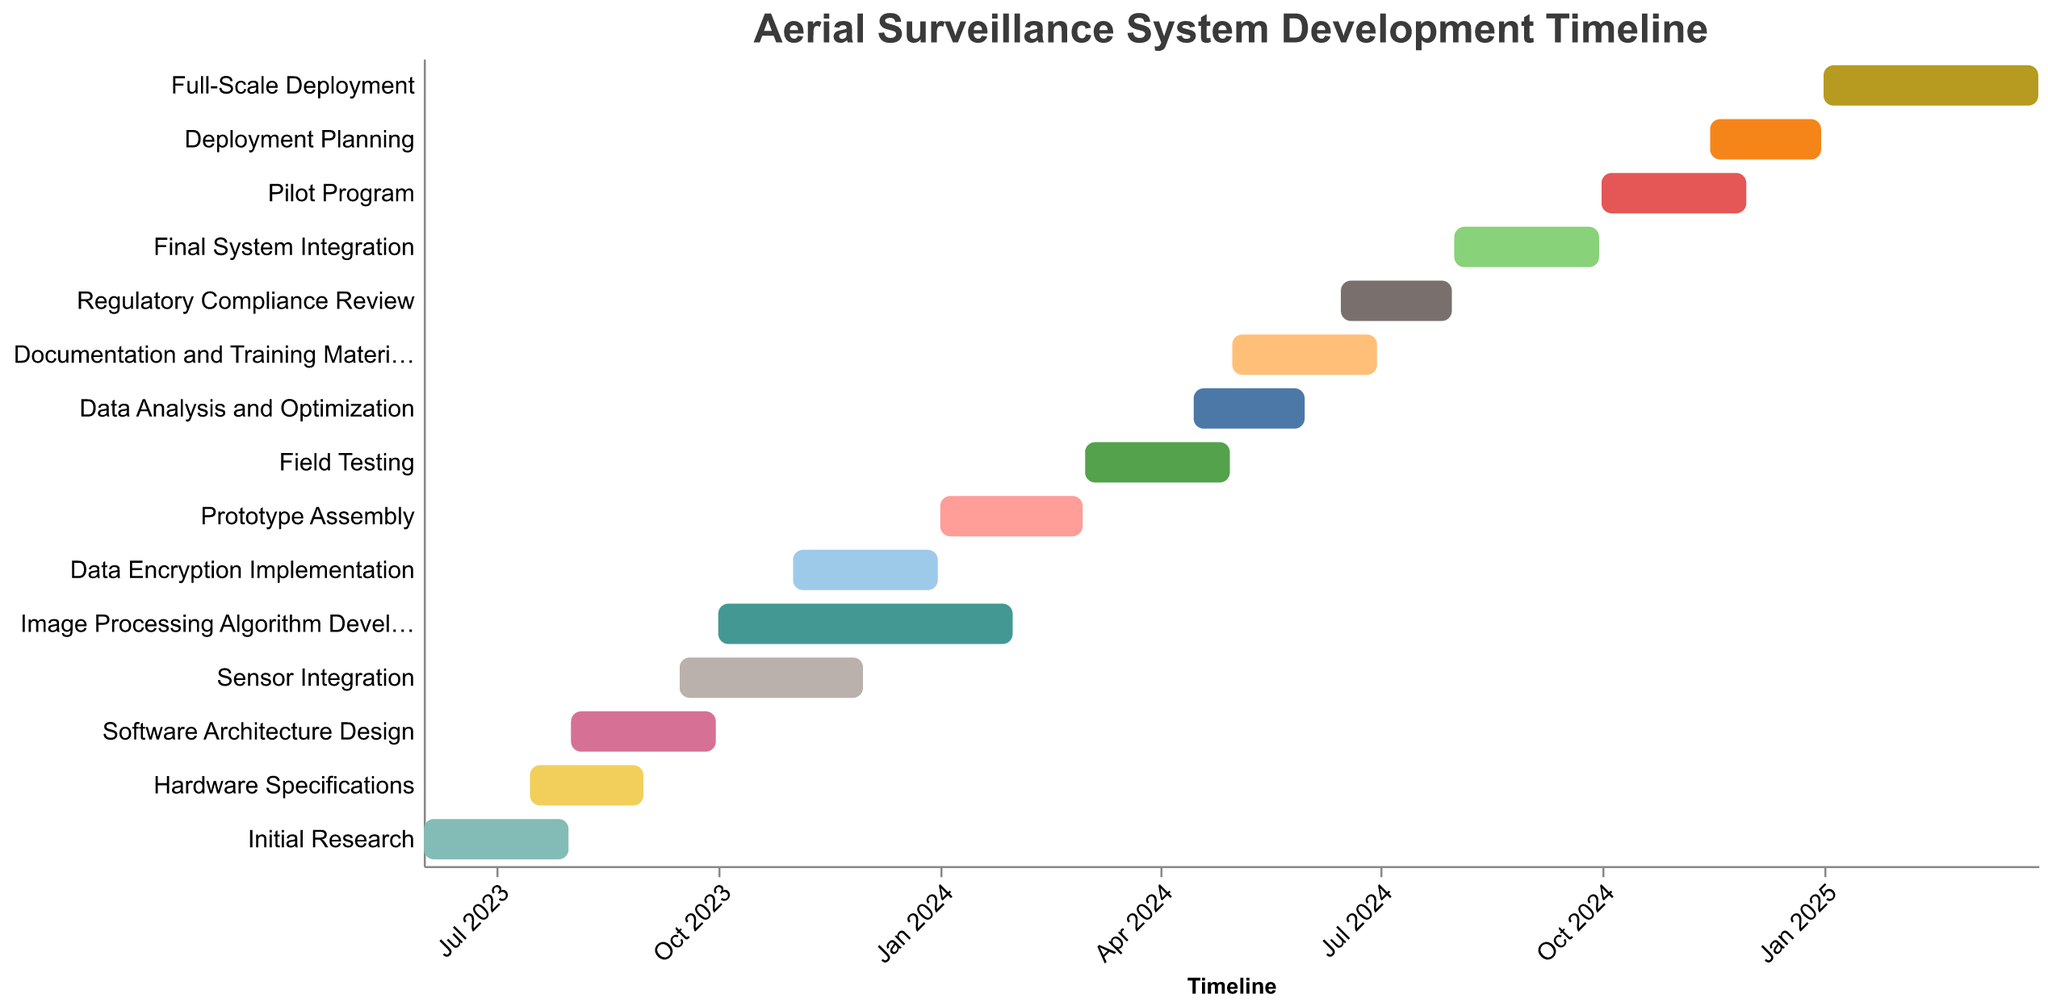What's the overall duration of the project from start to end? The project starts on 2023-06-01 and ends on 2025-03-31. The duration can be calculated by finding the difference between these two dates.
Answer: 669 days Which task has the longest duration? By comparing the durations listed, "Image Processing Algorithm Development" has the longest at 123 days.
Answer: Image Processing Algorithm Development How many tasks take place in the year 2023? Tasks happening in 2023 include Initial Research, Hardware Specifications, Software Architecture Design, Sensor Integration, Image Processing Algorithm Development, and Data Encryption Implementation.
Answer: 6 tasks Which tasks overlap with the "Sensor Integration" phase? The "Sensor Integration" phase runs from 2023-09-15 to 2023-11-30. Overlapping tasks include "Software Architecture Design", "Image Processing Algorithm Development", and "Data Encryption Implementation".
Answer: Software Architecture Design, Image Processing Algorithm Development, Data Encryption Implementation How long is the gap between the end of "Prototype Assembly" and the start of "Field Testing"? "Prototype Assembly" ends on 2024-02-29, and "Field Testing" starts on 2024-03-01. There is no gap between these two tasks.
Answer: No gap Which task begins immediately after "Regulatory Compliance Review"? "Regulatory Compliance Review" ends on 2024-07-31, and the next task starting immediately after this date is "Final System Integration" starting on 2024-08-01.
Answer: Final System Integration Which tasks finish in December 2024? Only "Deployment Planning" finishes in December 2024, specifically on 2024-12-31.
Answer: Deployment Planning What is the shortest task in the project? By comparing the durations of all tasks, "Data Analysis and Optimization" and "Regulatory Compliance Review" both have the shortest duration at 47 days each.
Answer: Data Analysis and Optimization, Regulatory Compliance Review What percentage of the project duration is spent on "Full-Scale Deployment"? "Full-Scale Deployment" lasts 90 days. The overall project duration is 669 days. The percentage can be calculated as (90/669) * 100 ≈ 13.45%.
Answer: 13.45% 